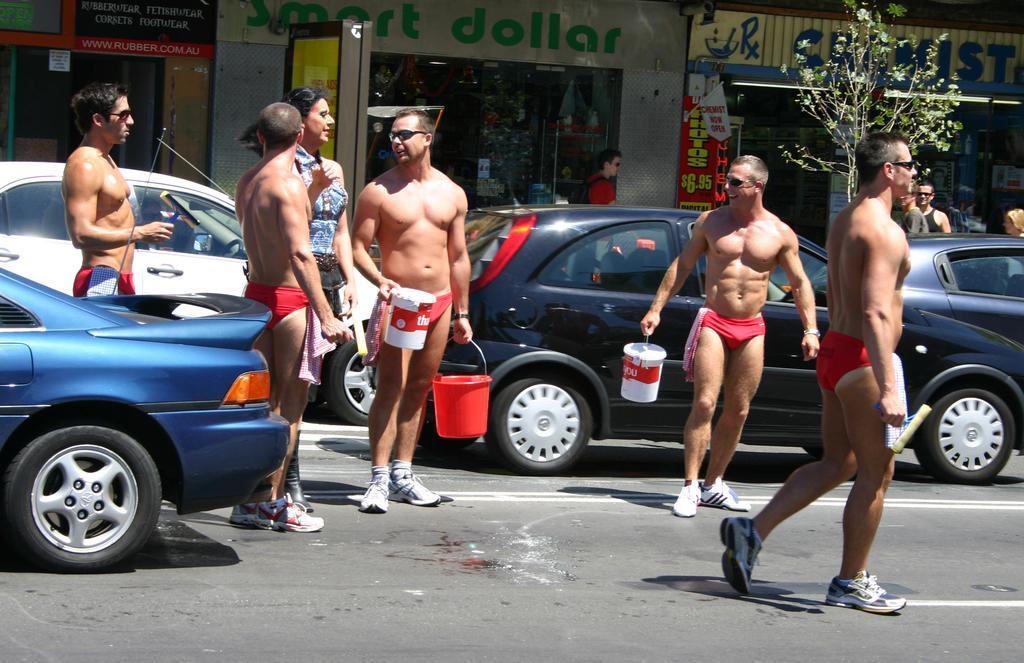Can you describe this image briefly? In this image we can see group of persons are standing on the road, they are holding a bucket in the hand, there are cars travelling on the road, there is a tree, there are shops, there is a sign board. 